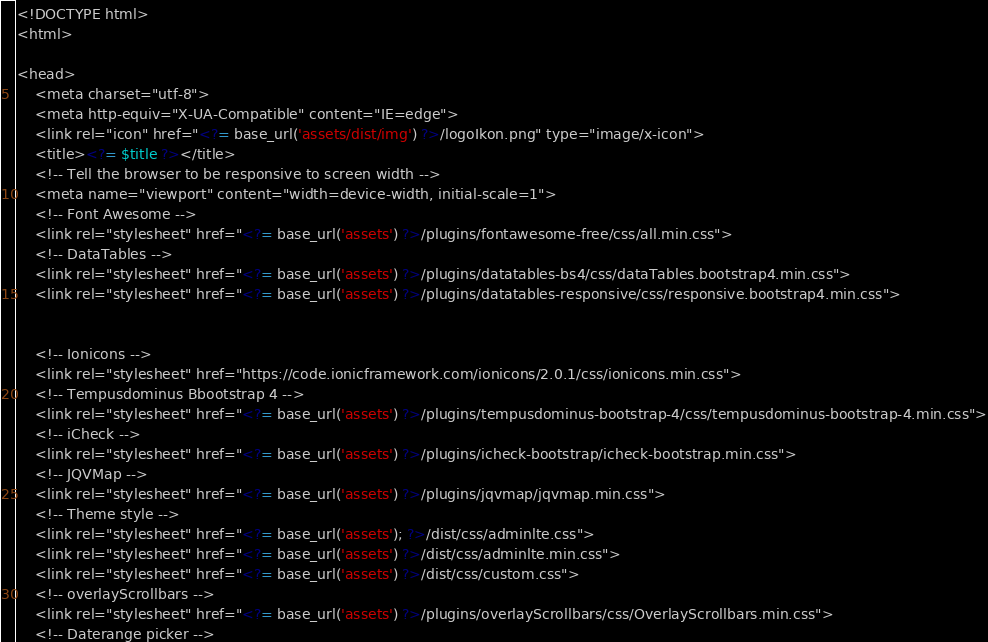Convert code to text. <code><loc_0><loc_0><loc_500><loc_500><_PHP_><!DOCTYPE html>
<html>

<head>
    <meta charset="utf-8">
    <meta http-equiv="X-UA-Compatible" content="IE=edge">
    <link rel="icon" href="<?= base_url('assets/dist/img') ?>/logoIkon.png" type="image/x-icon">
    <title><?= $title ?></title>
    <!-- Tell the browser to be responsive to screen width -->
    <meta name="viewport" content="width=device-width, initial-scale=1">
    <!-- Font Awesome -->
    <link rel="stylesheet" href="<?= base_url('assets') ?>/plugins/fontawesome-free/css/all.min.css">
    <!-- DataTables -->
    <link rel="stylesheet" href="<?= base_url('assets') ?>/plugins/datatables-bs4/css/dataTables.bootstrap4.min.css">
    <link rel="stylesheet" href="<?= base_url('assets') ?>/plugins/datatables-responsive/css/responsive.bootstrap4.min.css">


    <!-- Ionicons -->
    <link rel="stylesheet" href="https://code.ionicframework.com/ionicons/2.0.1/css/ionicons.min.css">
    <!-- Tempusdominus Bbootstrap 4 -->
    <link rel="stylesheet" href="<?= base_url('assets') ?>/plugins/tempusdominus-bootstrap-4/css/tempusdominus-bootstrap-4.min.css">
    <!-- iCheck -->
    <link rel="stylesheet" href="<?= base_url('assets') ?>/plugins/icheck-bootstrap/icheck-bootstrap.min.css">
    <!-- JQVMap -->
    <link rel="stylesheet" href="<?= base_url('assets') ?>/plugins/jqvmap/jqvmap.min.css">
    <!-- Theme style -->
    <link rel="stylesheet" href="<?= base_url('assets'); ?>/dist/css/adminlte.css">
    <link rel="stylesheet" href="<?= base_url('assets') ?>/dist/css/adminlte.min.css">
    <link rel="stylesheet" href="<?= base_url('assets') ?>/dist/css/custom.css">
    <!-- overlayScrollbars -->
    <link rel="stylesheet" href="<?= base_url('assets') ?>/plugins/overlayScrollbars/css/OverlayScrollbars.min.css">
    <!-- Daterange picker --></code> 